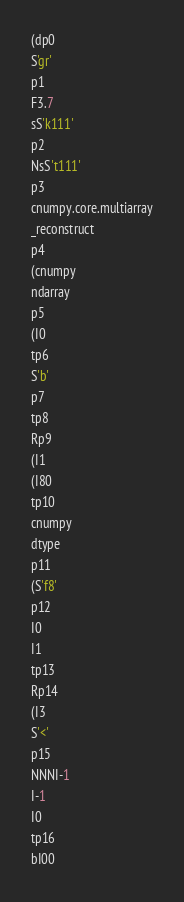Convert code to text. <code><loc_0><loc_0><loc_500><loc_500><_SQL_>(dp0
S'gr'
p1
F3.7
sS'k111'
p2
NsS't111'
p3
cnumpy.core.multiarray
_reconstruct
p4
(cnumpy
ndarray
p5
(I0
tp6
S'b'
p7
tp8
Rp9
(I1
(I80
tp10
cnumpy
dtype
p11
(S'f8'
p12
I0
I1
tp13
Rp14
(I3
S'<'
p15
NNNI-1
I-1
I0
tp16
bI00</code> 